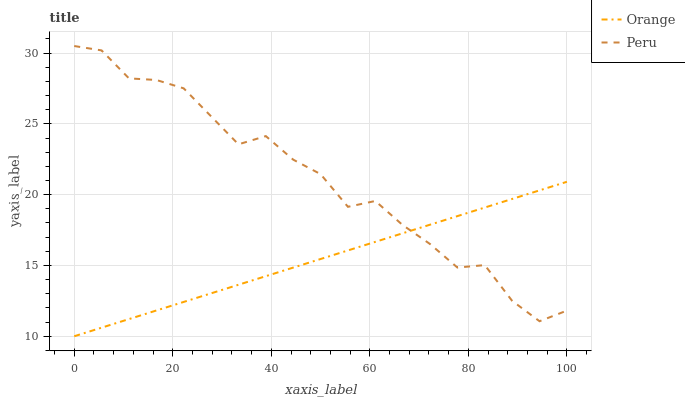Does Orange have the minimum area under the curve?
Answer yes or no. Yes. Does Peru have the maximum area under the curve?
Answer yes or no. Yes. Does Peru have the minimum area under the curve?
Answer yes or no. No. Is Orange the smoothest?
Answer yes or no. Yes. Is Peru the roughest?
Answer yes or no. Yes. Is Peru the smoothest?
Answer yes or no. No. Does Orange have the lowest value?
Answer yes or no. Yes. Does Peru have the lowest value?
Answer yes or no. No. Does Peru have the highest value?
Answer yes or no. Yes. Does Orange intersect Peru?
Answer yes or no. Yes. Is Orange less than Peru?
Answer yes or no. No. Is Orange greater than Peru?
Answer yes or no. No. 